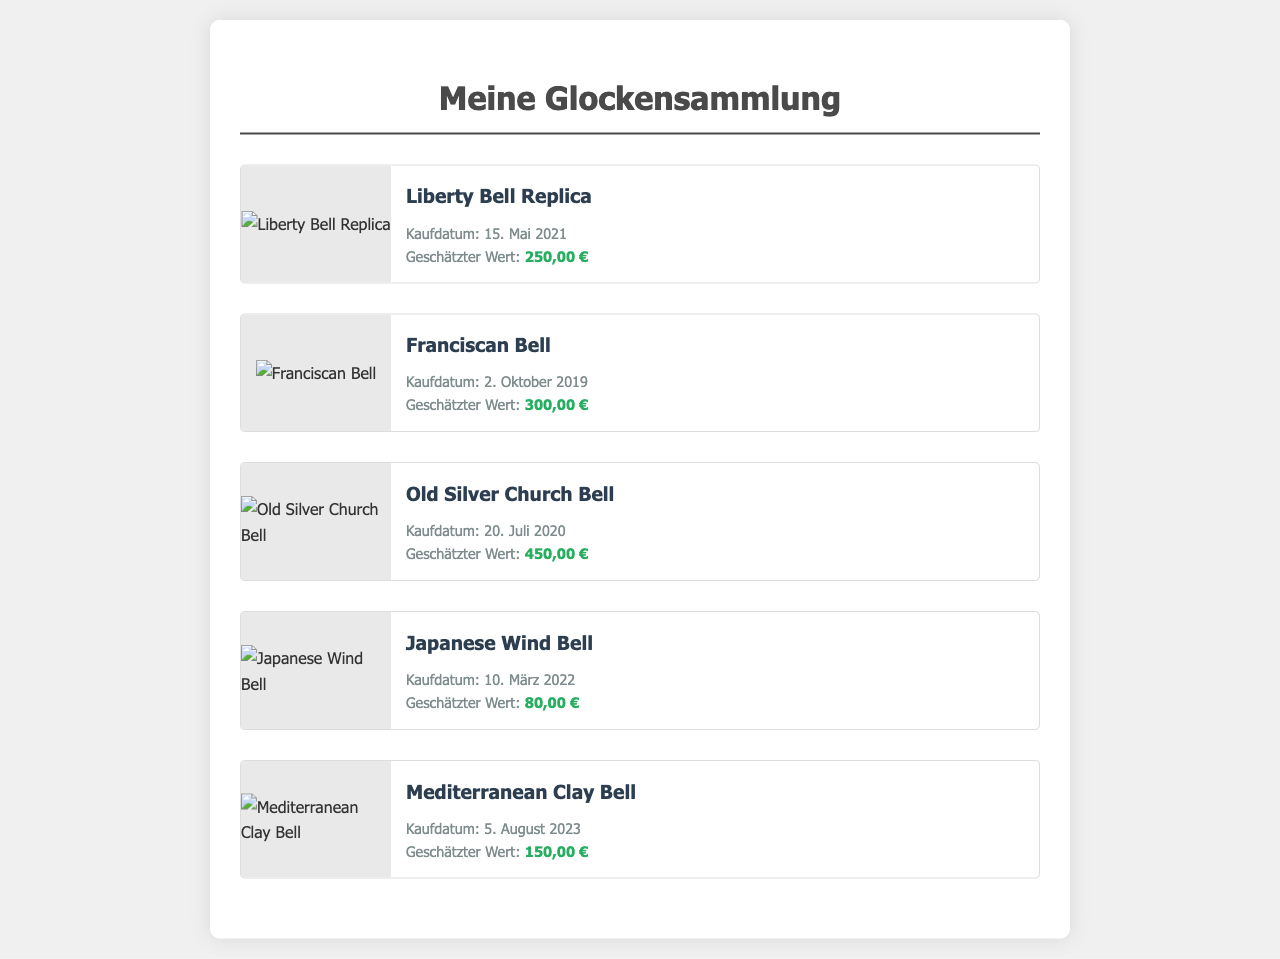Was ist der Name der ersten Glocke? Die erste Glocke in der Liste ist die "Liberty Bell Replica".
Answer: Liberty Bell Replica Wann wurde die Franciscan Bell gekauft? Das Kaufdatum der Franciscan Bell ist im Dokument angegeben.
Answer: 2. Oktober 2019 Was ist der geschätzte Wert der Old Silver Church Bell? Der geschätzte Wert ist ein spezifischer Wert, der in den Details zur Old Silver Church Bell angegeben ist.
Answer: 450,00 € Wie viele Glocken sind in der Sammlung? Die Anzahl der Glocken kann durch das Zählen der aufgeführten Glocken ermittelt werden.
Answer: 5 Was ist das Kaufdatum der Mediterranean Clay Bell? Das Kaufdatum steht in den Details zur Mediterranean Clay Bell.
Answer: 5. August 2023 Welche Glocke hat den niedrigsten geschätzten Wert? Um die Glocke mit dem niedrigsten Wert zu finden, werden die geschätzten Werte der Glocken verglichen.
Answer: Japanese Wind Bell Gibt es eine Glocke aus dem Jahr 2021? Um dies zu beantworten, wird auf die Kaufdaten im Dokument geschaut.
Answer: Ja Wer ist der Hersteller der Glocken? In diesem Dokument sind keinerlei Informationen über Hersteller der Glocken angegeben.
Answer: Keine Information 